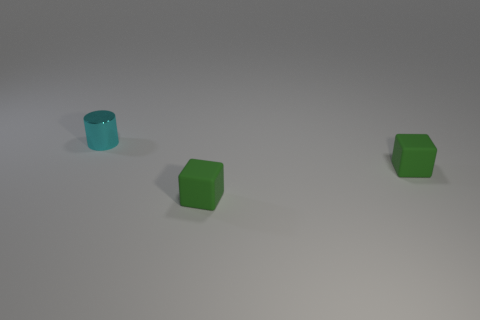There is a tiny shiny thing; are there any cubes behind it? Actually, the scene does not contain any tiny shiny objects. There are two cubes visible, and neither has anything behind it. Both cubes are resting on a flat surface, spaced apart without any additional objects in the vicinity. 